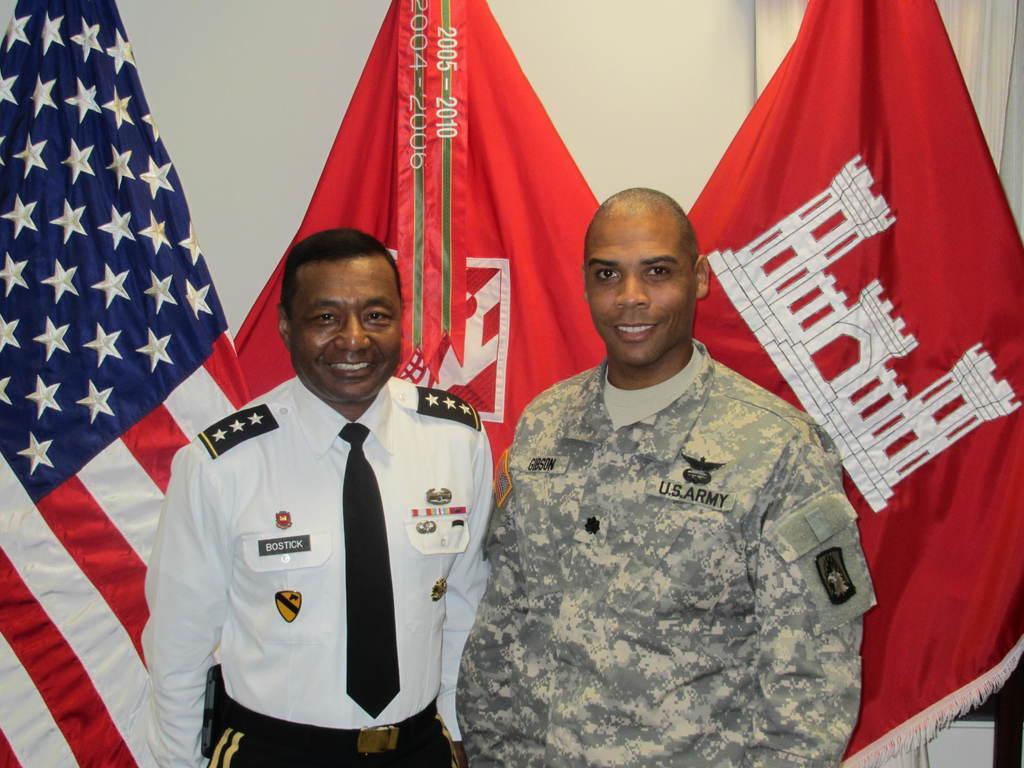In one or two sentences, can you explain what this image depicts? Here in this picture we can see two persons standing over there and both of them are smiling and behind them we can see different countries flag posts present over there. 